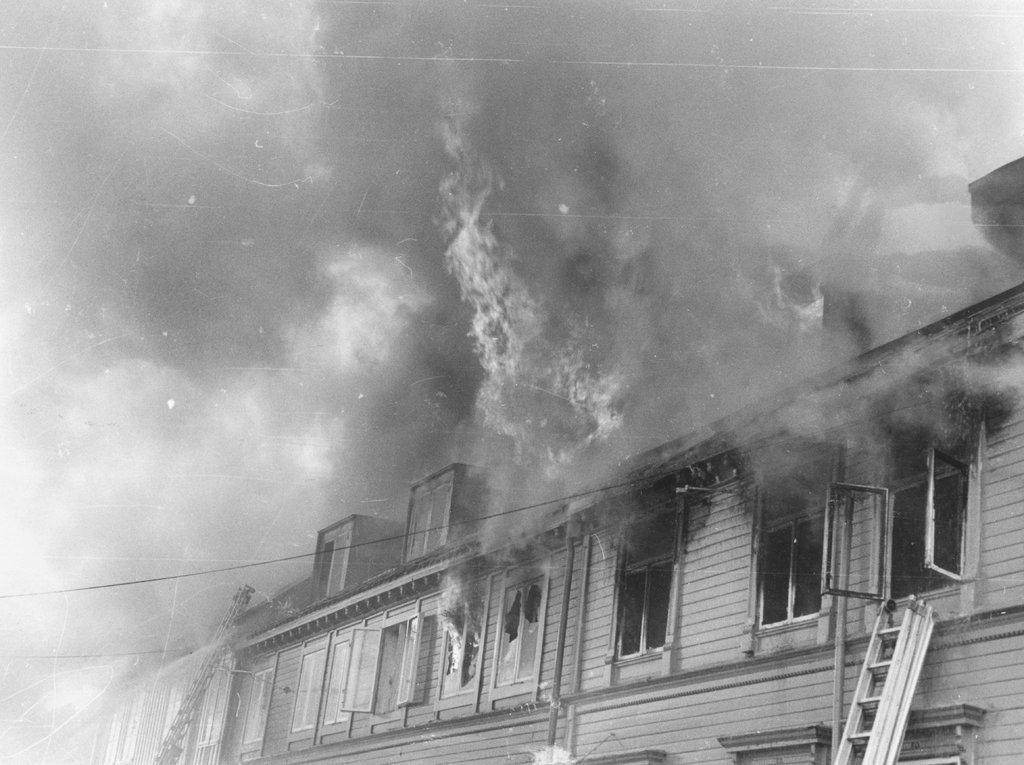How would you summarize this image in a sentence or two? In this image there is a building with fire, in front of the building there are ladders. In the background there are the sky and smoke. 